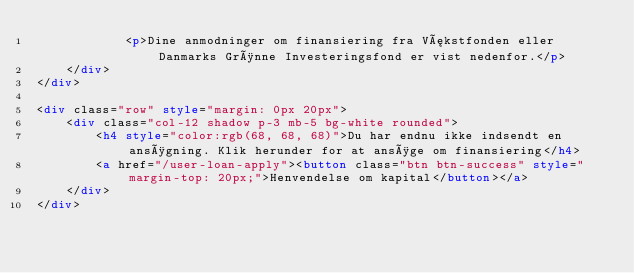Convert code to text. <code><loc_0><loc_0><loc_500><loc_500><_HTML_>            <p>Dine anmodninger om finansiering fra Vækstfonden eller Danmarks Grønne Investeringsfond er vist nedenfor.</p>
    </div>
</div>   

<div class="row" style="margin: 0px 20px">
    <div class="col-12 shadow p-3 mb-5 bg-white rounded">
        <h4 style="color:rgb(68, 68, 68)">Du har endnu ikke indsendt en ansøgning. Klik herunder for at ansøge om finansiering</h4>
        <a href="/user-loan-apply"><button class="btn btn-success" style="margin-top: 20px;">Henvendelse om kapital</button></a>
    </div>
</div>
</code> 